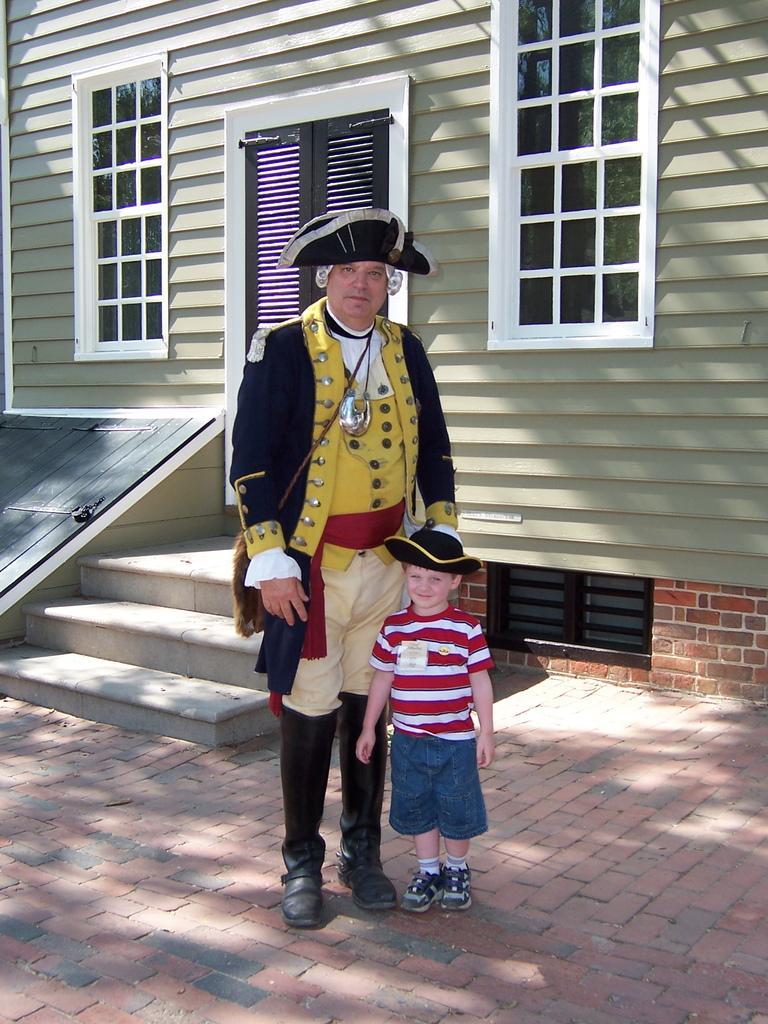Please provide a concise description of this image. There is a man and a small boy standing in the foreground area of the image, there are stairs and a house in the background. 